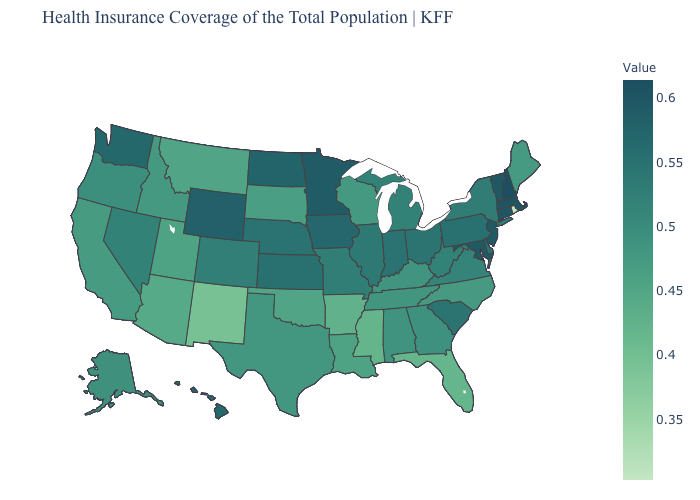Does New Mexico have the lowest value in the West?
Be succinct. Yes. Which states have the lowest value in the USA?
Answer briefly. Rhode Island. Among the states that border South Dakota , does Nebraska have the highest value?
Concise answer only. No. Among the states that border Florida , which have the highest value?
Answer briefly. Georgia. Which states have the lowest value in the West?
Short answer required. New Mexico. Which states have the highest value in the USA?
Give a very brief answer. New Hampshire. Which states hav the highest value in the MidWest?
Keep it brief. Minnesota. 